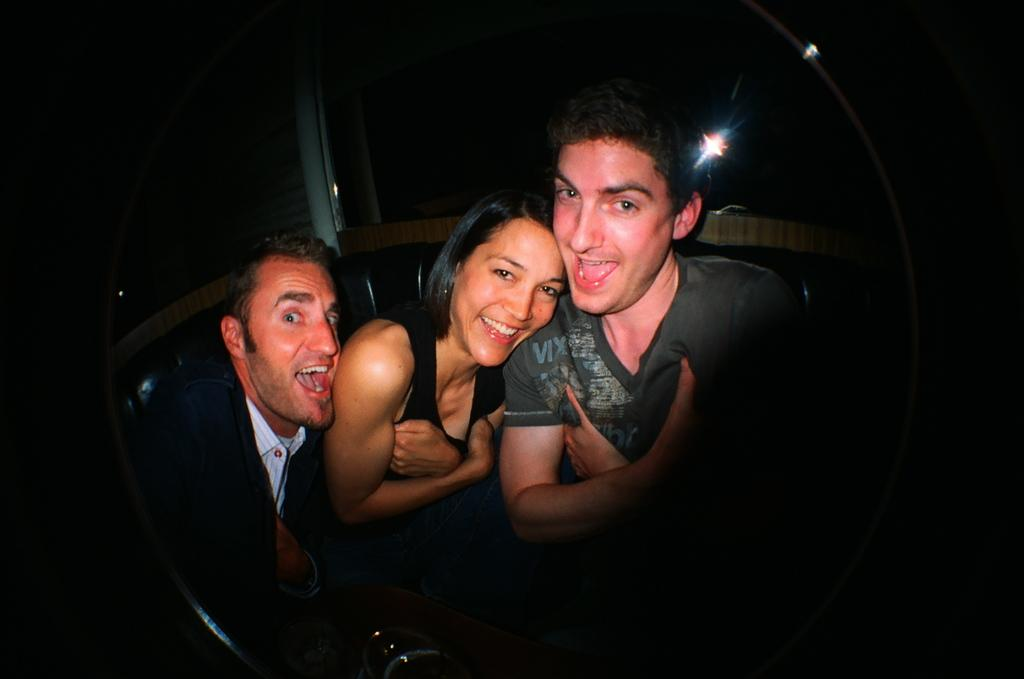How many people are in the image? There are three people in the image. What is the facial expression of the people in the image? The people are smiling. What are the people doing in the image? The people are posing for a picture. Where is the image likely to have been taken? The setting appears to be a lift. What type of family is depicted in the image? There is no information about the family relationship of the people in the image, so it cannot be determined. How does the lift help the people in the image? The image does not show the lift in operation or provide any context for how it might be helping the people, so it cannot be determined. 